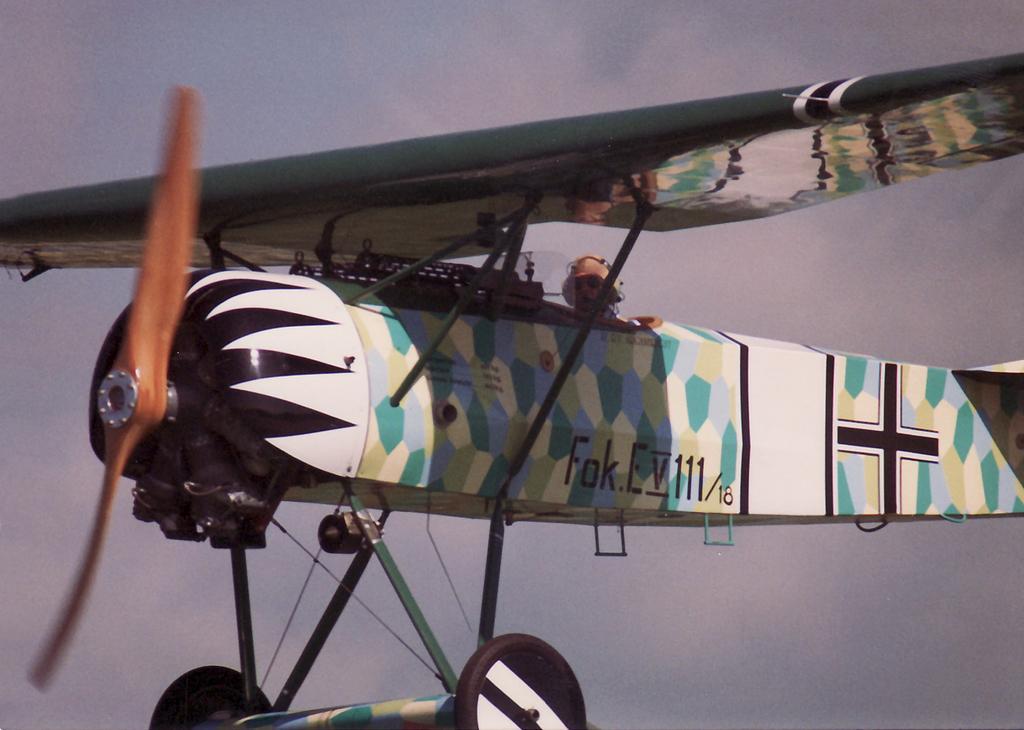How would you summarize this image in a sentence or two? In the foreground of the image, there is an airplane in the air and a man in it. In the background, there is the sky. 